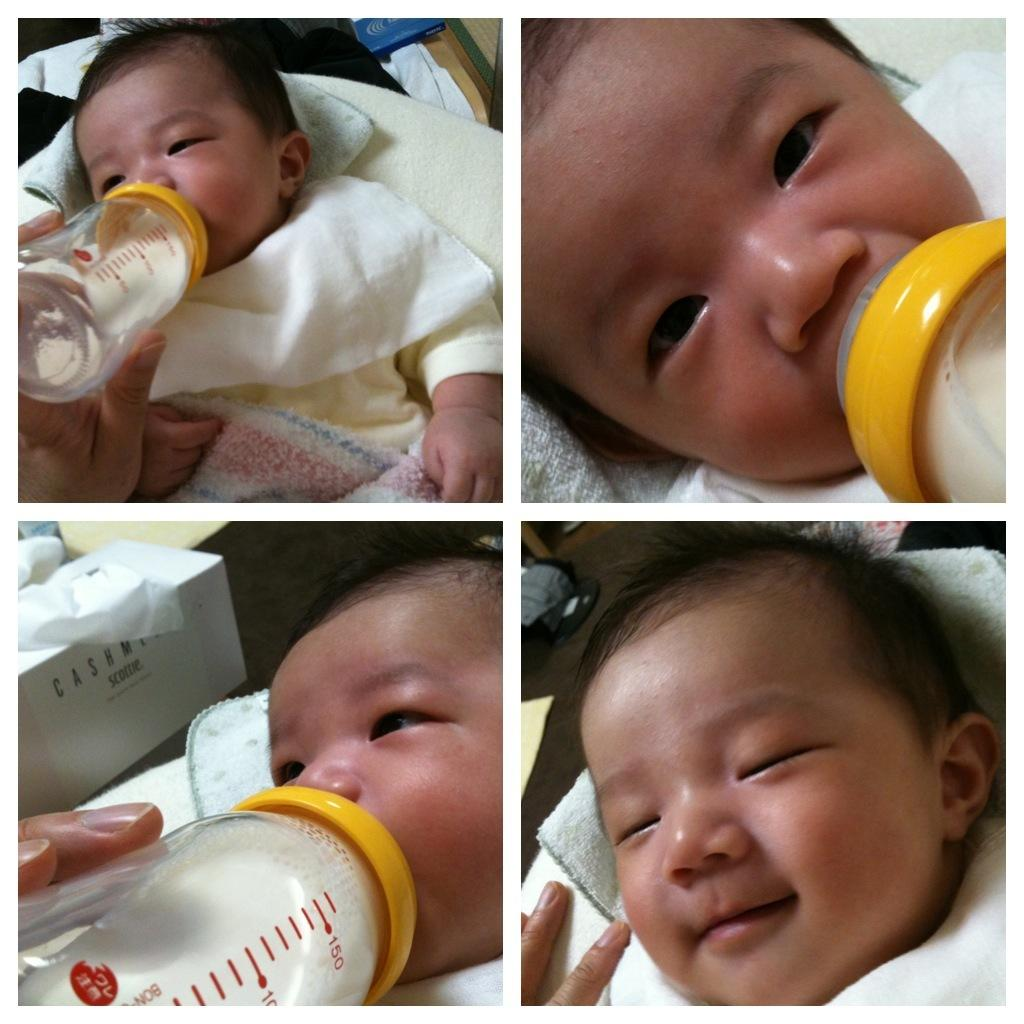What is the main subject of the image? There is a baby in the image. What is the baby doing in the image? The baby is drinking milk from a bottle. Can you describe the context of the image? The image is part of a collage. What type of prison bars can be seen in the image? There are no prison bars present in the image; it features a baby drinking milk from a bottle. What kind of steel material is visible in the image? There is no steel material visible in the image. 